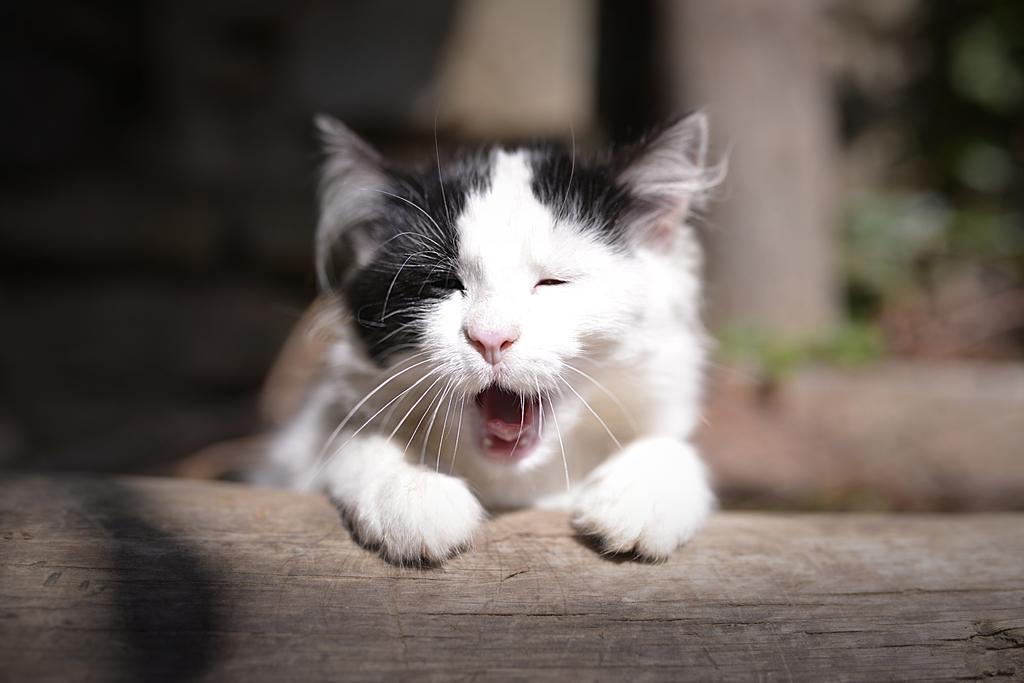Could you give a brief overview of what you see in this image? In this image in the foreground there is one cat and there is a blurry background, at the bottom there might be a wooden pole. 